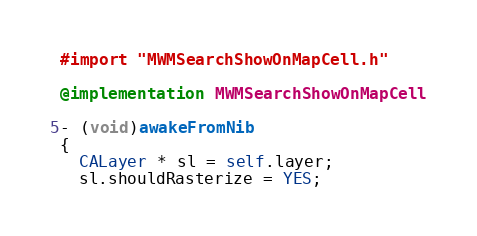<code> <loc_0><loc_0><loc_500><loc_500><_ObjectiveC_>#import "MWMSearchShowOnMapCell.h"

@implementation MWMSearchShowOnMapCell

- (void)awakeFromNib
{
  CALayer * sl = self.layer;
  sl.shouldRasterize = YES;</code> 